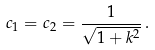<formula> <loc_0><loc_0><loc_500><loc_500>c _ { 1 } = c _ { 2 } = \frac { 1 } { \sqrt { 1 + k ^ { 2 } } } \, .</formula> 